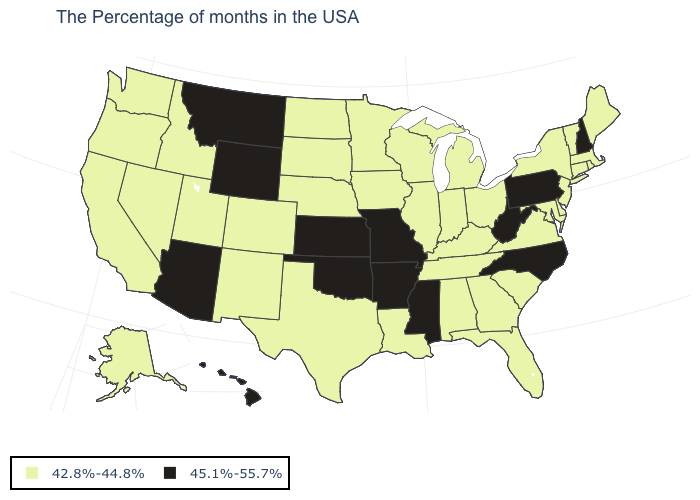Does the first symbol in the legend represent the smallest category?
Give a very brief answer. Yes. What is the value of Rhode Island?
Write a very short answer. 42.8%-44.8%. How many symbols are there in the legend?
Be succinct. 2. Which states have the lowest value in the West?
Be succinct. Colorado, New Mexico, Utah, Idaho, Nevada, California, Washington, Oregon, Alaska. What is the lowest value in the USA?
Quick response, please. 42.8%-44.8%. Does Utah have the highest value in the West?
Short answer required. No. Does North Carolina have the lowest value in the USA?
Short answer required. No. Which states have the highest value in the USA?
Concise answer only. New Hampshire, Pennsylvania, North Carolina, West Virginia, Mississippi, Missouri, Arkansas, Kansas, Oklahoma, Wyoming, Montana, Arizona, Hawaii. What is the lowest value in states that border Montana?
Be succinct. 42.8%-44.8%. What is the value of New Mexico?
Answer briefly. 42.8%-44.8%. What is the highest value in the USA?
Keep it brief. 45.1%-55.7%. Does Kentucky have a lower value than Indiana?
Quick response, please. No. Name the states that have a value in the range 42.8%-44.8%?
Write a very short answer. Maine, Massachusetts, Rhode Island, Vermont, Connecticut, New York, New Jersey, Delaware, Maryland, Virginia, South Carolina, Ohio, Florida, Georgia, Michigan, Kentucky, Indiana, Alabama, Tennessee, Wisconsin, Illinois, Louisiana, Minnesota, Iowa, Nebraska, Texas, South Dakota, North Dakota, Colorado, New Mexico, Utah, Idaho, Nevada, California, Washington, Oregon, Alaska. How many symbols are there in the legend?
Keep it brief. 2. Among the states that border Pennsylvania , which have the highest value?
Quick response, please. West Virginia. 